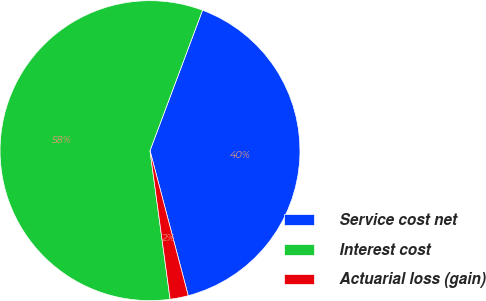Convert chart to OTSL. <chart><loc_0><loc_0><loc_500><loc_500><pie_chart><fcel>Service cost net<fcel>Interest cost<fcel>Actuarial loss (gain)<nl><fcel>40.2%<fcel>57.84%<fcel>1.96%<nl></chart> 